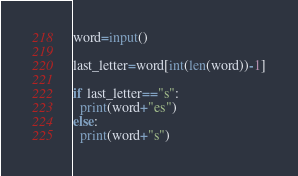Convert code to text. <code><loc_0><loc_0><loc_500><loc_500><_Python_>word=input()

last_letter=word[int(len(word))-1]

if last_letter=="s":
  print(word+"es")
else:
  print(word+"s")</code> 